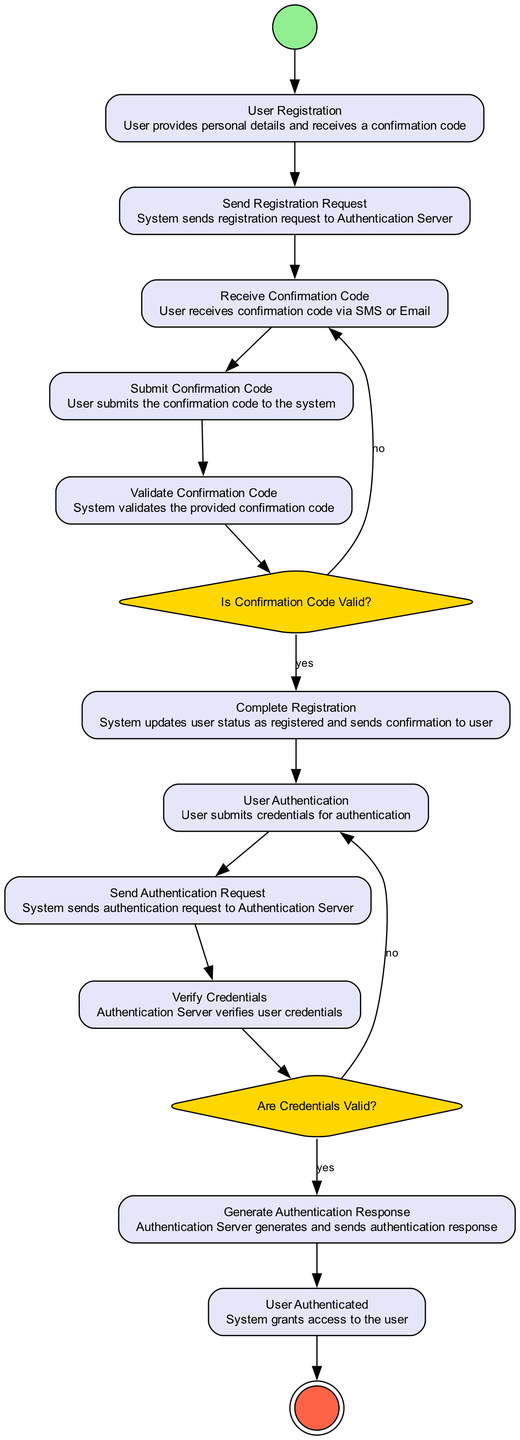What is the first activity in the diagram? The first activity is labeled "Start," which represents the initial point of the process.
Answer: Start How many actions are labeled in the diagram? There are 12 action nodes defined in the "Activities" section of the data, which include steps like "User Registration" and "Validate Confirmation Code."
Answer: 12 What happens if the confirmation code is invalid? If the confirmation code is invalid, the flow leads back to the "Receive Confirmation Code" node, indicating that the user must receive a new code.
Answer: Receive Confirmation Code What node follows "User Authentication"? The node that follows "User Authentication" is "Send Authentication Request." This shows the process flow from the user submitting their credentials to the system's response.
Answer: Send Authentication Request What is the condition checked after "Validate Confirmation Code"? The condition checked after "Validate Confirmation Code" is "Is Confirmation Code Valid?" which determines whether to proceed with registration or request a new confirmation code.
Answer: Is Confirmation Code Valid? How many final nodes are there in the diagram? There is one final node in the diagram, which marks the end of the authentication protocol process. It is labeled "End."
Answer: 1 What does the system do after receiving a confirmation code? After receiving the confirmation code, the system waits for the user to submit it through the "Submit Confirmation Code" action node.
Answer: Submit Confirmation Code What is the last action taken in the user authentication process? The last action taken in the user authentication process is "User Authenticated," where the system grants access to the user.
Answer: User Authenticated What activity immediately precedes "Generate Authentication Response"? The activity that immediately precedes "Generate Authentication Response" is "Are Credentials Valid?" that checks if the user's submitted credentials are correct.
Answer: Are Credentials Valid? 